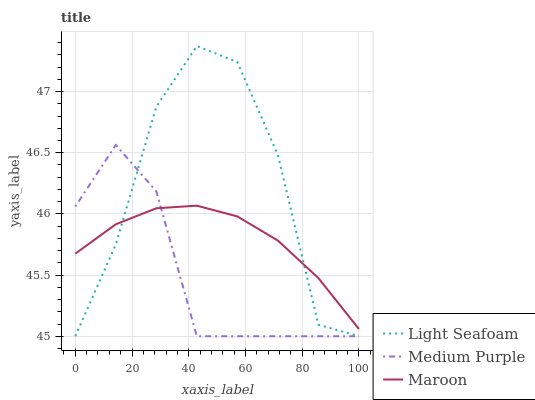Does Medium Purple have the minimum area under the curve?
Answer yes or no. Yes. Does Light Seafoam have the maximum area under the curve?
Answer yes or no. Yes. Does Maroon have the minimum area under the curve?
Answer yes or no. No. Does Maroon have the maximum area under the curve?
Answer yes or no. No. Is Maroon the smoothest?
Answer yes or no. Yes. Is Light Seafoam the roughest?
Answer yes or no. Yes. Is Light Seafoam the smoothest?
Answer yes or no. No. Is Maroon the roughest?
Answer yes or no. No. Does Medium Purple have the lowest value?
Answer yes or no. Yes. Does Maroon have the lowest value?
Answer yes or no. No. Does Light Seafoam have the highest value?
Answer yes or no. Yes. Does Maroon have the highest value?
Answer yes or no. No. Does Light Seafoam intersect Maroon?
Answer yes or no. Yes. Is Light Seafoam less than Maroon?
Answer yes or no. No. Is Light Seafoam greater than Maroon?
Answer yes or no. No. 